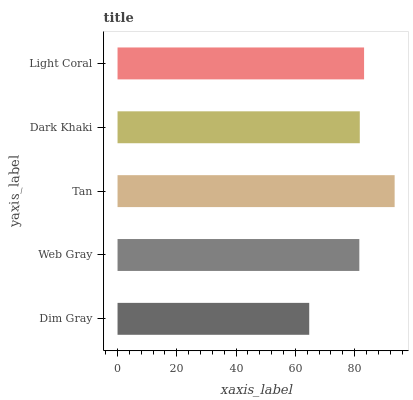Is Dim Gray the minimum?
Answer yes or no. Yes. Is Tan the maximum?
Answer yes or no. Yes. Is Web Gray the minimum?
Answer yes or no. No. Is Web Gray the maximum?
Answer yes or no. No. Is Web Gray greater than Dim Gray?
Answer yes or no. Yes. Is Dim Gray less than Web Gray?
Answer yes or no. Yes. Is Dim Gray greater than Web Gray?
Answer yes or no. No. Is Web Gray less than Dim Gray?
Answer yes or no. No. Is Dark Khaki the high median?
Answer yes or no. Yes. Is Dark Khaki the low median?
Answer yes or no. Yes. Is Web Gray the high median?
Answer yes or no. No. Is Dim Gray the low median?
Answer yes or no. No. 